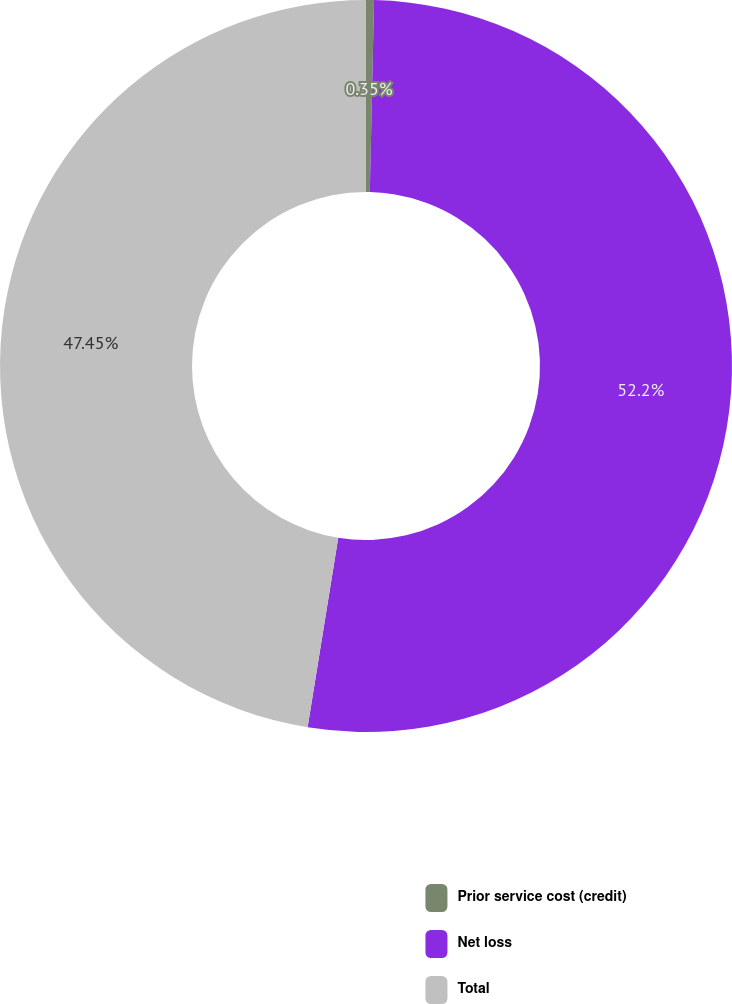<chart> <loc_0><loc_0><loc_500><loc_500><pie_chart><fcel>Prior service cost (credit)<fcel>Net loss<fcel>Total<nl><fcel>0.35%<fcel>52.2%<fcel>47.45%<nl></chart> 